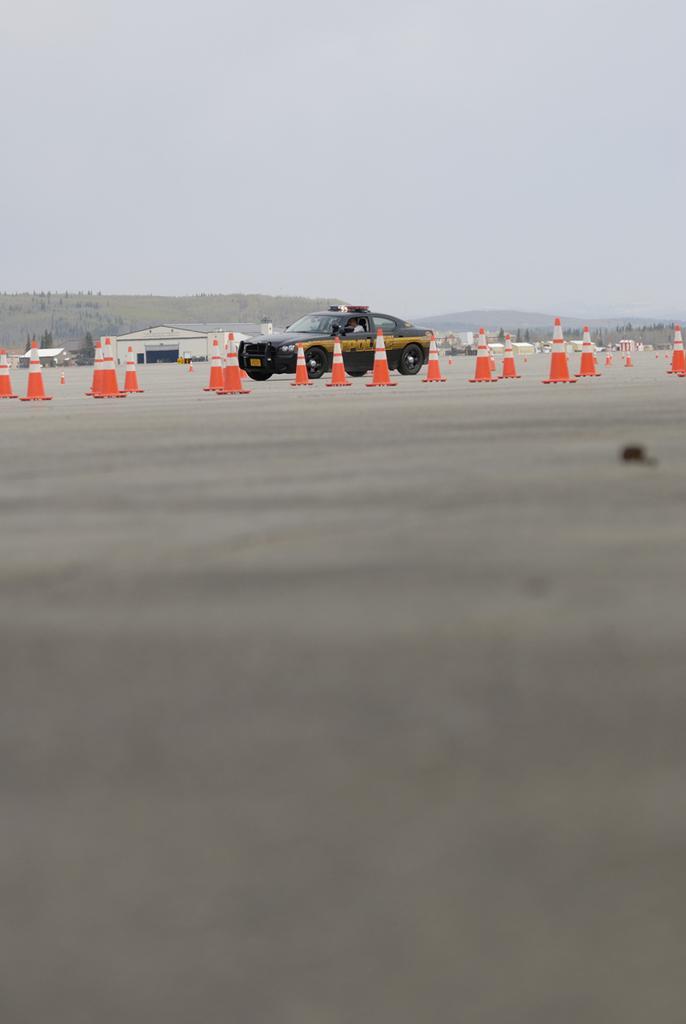Describe this image in one or two sentences. We can see many traffic cones. Also there is a black car. In the back there are hills and sky. 